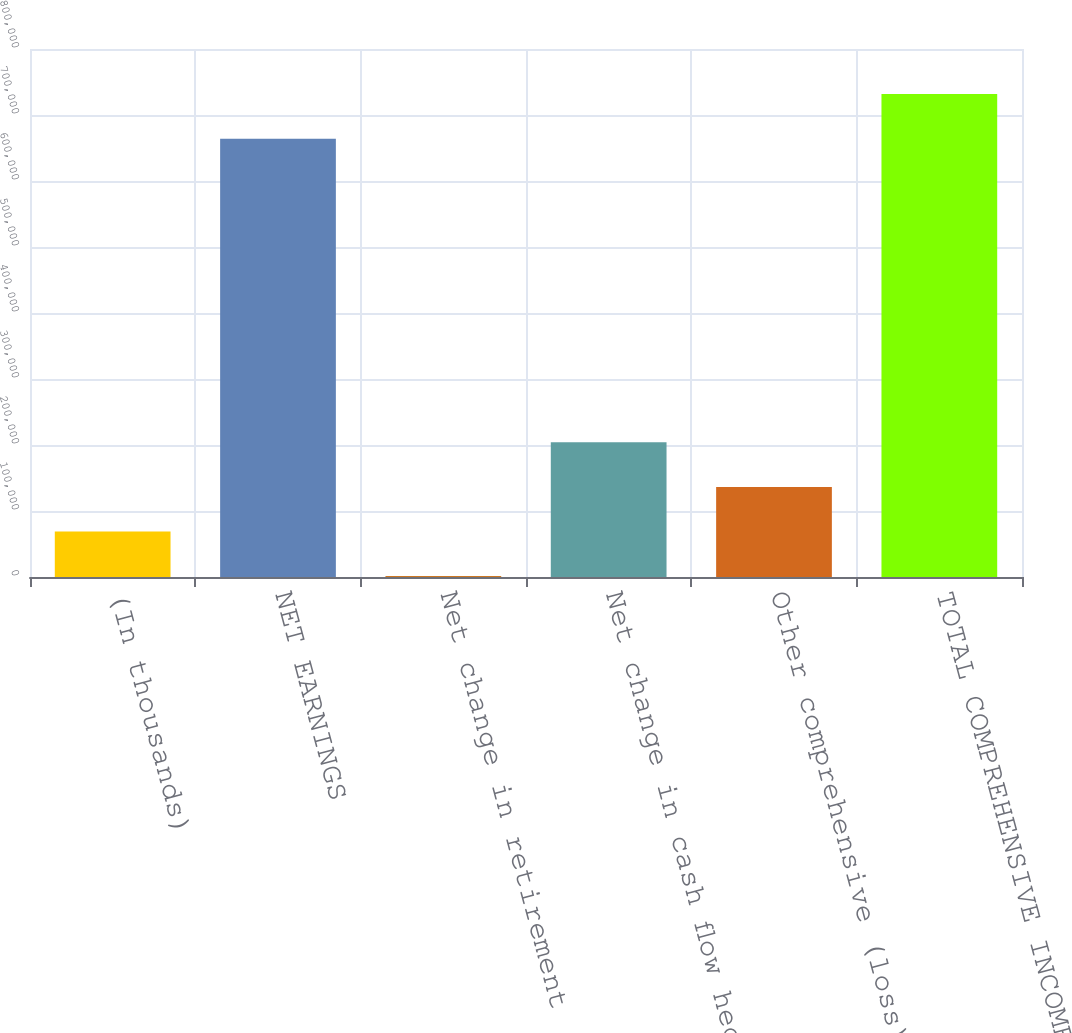<chart> <loc_0><loc_0><loc_500><loc_500><bar_chart><fcel>(In thousands)<fcel>NET EARNINGS<fcel>Net change in retirement<fcel>Net change in cash flow hedge<fcel>Other comprehensive (loss)<fcel>TOTAL COMPREHENSIVE INCOME<nl><fcel>68927.4<fcel>664112<fcel>1371<fcel>204040<fcel>136484<fcel>731668<nl></chart> 